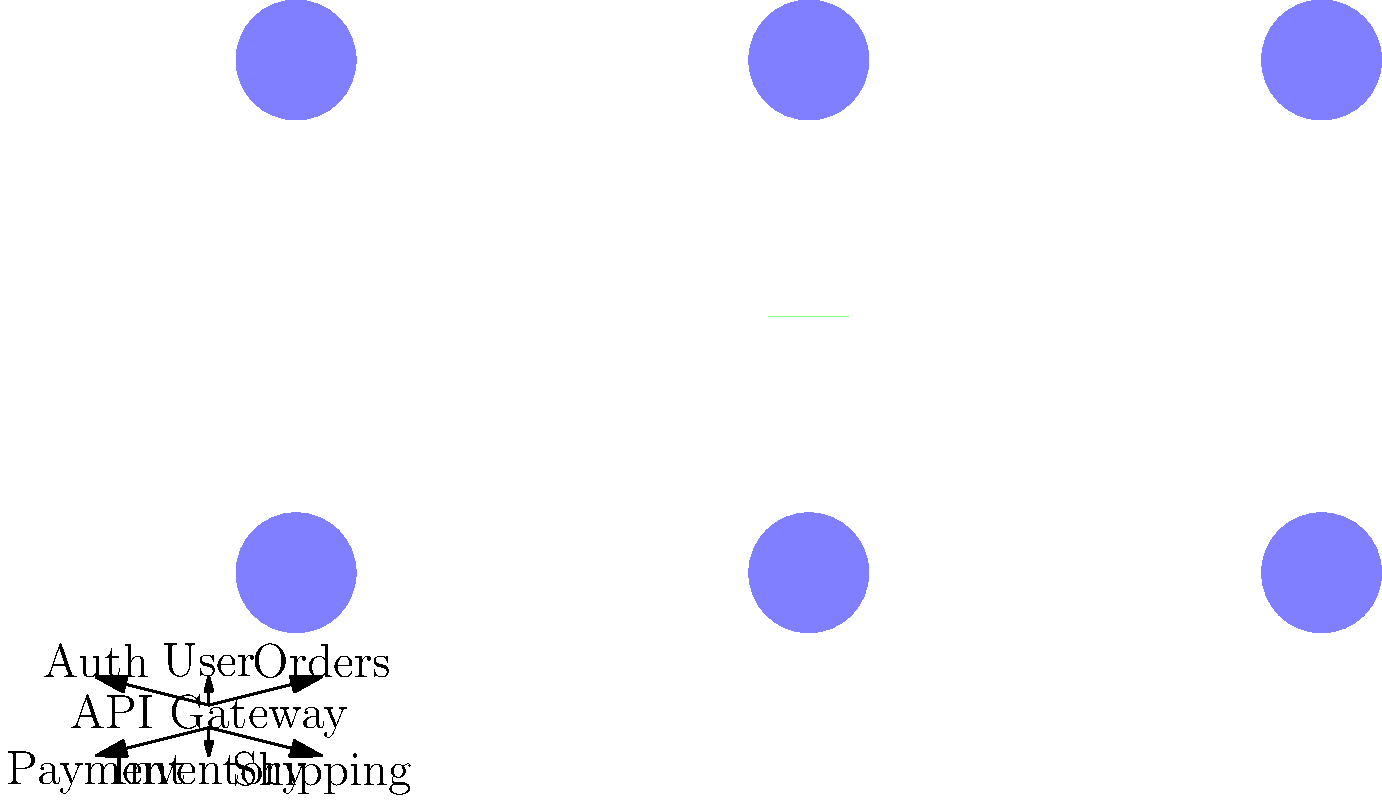In the given microservices architecture diagram, which component is most likely responsible for handling cross-cutting concerns such as authentication, rate limiting, and request routing? To answer this question, let's analyze the components in the diagram:

1. We see six circular nodes representing different microservices: Auth, User, Orders, Payment, Inventory, and Shipping.

2. In the center, there's a rectangular component labeled "API Gateway".

3. All connections between the microservices pass through the API Gateway.

4. In a microservices architecture, cross-cutting concerns are typically handled by a component that sits between the clients and the individual services.

5. The API Gateway is positioned perfectly to intercept all incoming requests before they reach the individual microservices.

6. API Gateways are commonly used to handle tasks such as:
   - Authentication and authorization
   - Rate limiting to prevent abuse
   - Request routing to appropriate microservices
   - Load balancing
   - Protocol translation

7. Given its central position and typical responsibilities, the API Gateway is the component most likely to handle these cross-cutting concerns.

Therefore, based on the diagram and common microservices patterns, the API Gateway is the correct answer.
Answer: API Gateway 